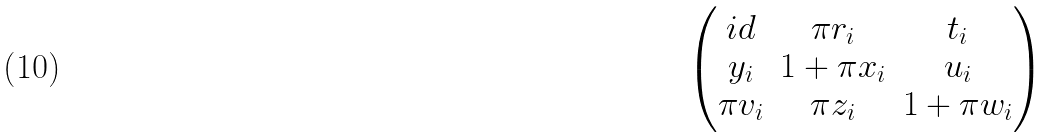Convert formula to latex. <formula><loc_0><loc_0><loc_500><loc_500>\begin{pmatrix} i d & \pi r _ { i } & t _ { i } \\ y _ { i } & 1 + \pi x _ { i } & u _ { i } \\ \pi v _ { i } & \pi z _ { i } & 1 + \pi w _ { i } \end{pmatrix}</formula> 